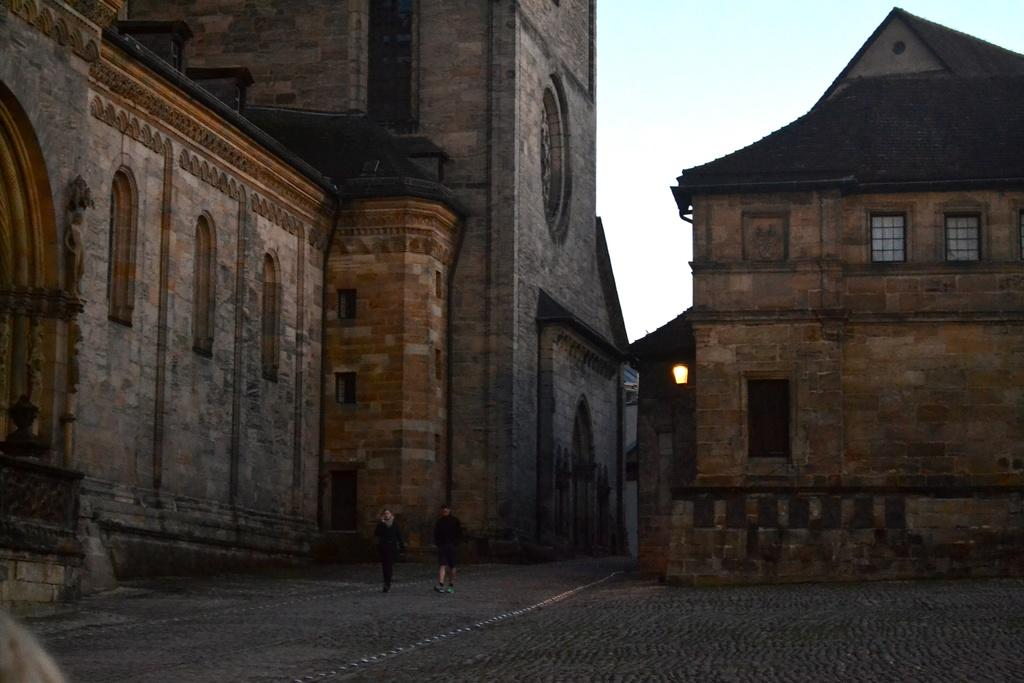What are the two people in the image doing? The two people in the image are walking. What is the surface they are walking on made of? The path they are walking on is made of cobblestone. What can be seen in the background of the image? There are buildings in the background of the image. Can you describe the lighting in the image? A light is attached to the wall of a building in the image. What is visible at the top of the image? The sky is visible at the top of the image. What type of dress is the mom wearing in the image? There is no mom present in the image, and no one is wearing a dress. 